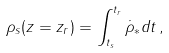Convert formula to latex. <formula><loc_0><loc_0><loc_500><loc_500>\rho _ { s } ( z = z _ { r } ) = \int _ { t _ { s } } ^ { t _ { r } } \dot { \rho } _ { \ast } d t \, ,</formula> 